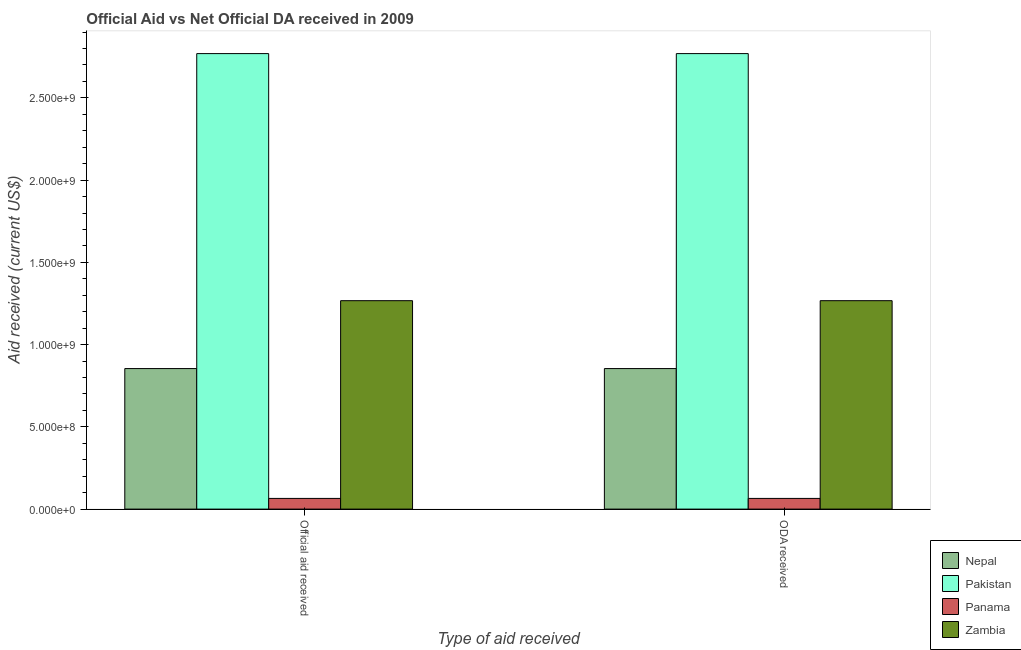How many different coloured bars are there?
Keep it short and to the point. 4. How many groups of bars are there?
Provide a short and direct response. 2. Are the number of bars on each tick of the X-axis equal?
Your answer should be very brief. Yes. How many bars are there on the 1st tick from the left?
Provide a succinct answer. 4. How many bars are there on the 1st tick from the right?
Provide a succinct answer. 4. What is the label of the 1st group of bars from the left?
Offer a terse response. Official aid received. What is the official aid received in Panama?
Your response must be concise. 6.50e+07. Across all countries, what is the maximum oda received?
Offer a terse response. 2.77e+09. Across all countries, what is the minimum oda received?
Your response must be concise. 6.50e+07. In which country was the oda received minimum?
Offer a very short reply. Panama. What is the total oda received in the graph?
Provide a succinct answer. 4.96e+09. What is the difference between the official aid received in Nepal and that in Zambia?
Keep it short and to the point. -4.13e+08. What is the difference between the oda received in Pakistan and the official aid received in Nepal?
Ensure brevity in your answer.  1.91e+09. What is the average official aid received per country?
Provide a succinct answer. 1.24e+09. What is the difference between the oda received and official aid received in Panama?
Your answer should be compact. 0. What is the ratio of the oda received in Panama to that in Pakistan?
Offer a very short reply. 0.02. Is the official aid received in Zambia less than that in Pakistan?
Give a very brief answer. Yes. What does the 4th bar from the left in ODA received represents?
Ensure brevity in your answer.  Zambia. What does the 1st bar from the right in ODA received represents?
Make the answer very short. Zambia. How many bars are there?
Keep it short and to the point. 8. Are all the bars in the graph horizontal?
Ensure brevity in your answer.  No. How many countries are there in the graph?
Provide a short and direct response. 4. What is the difference between two consecutive major ticks on the Y-axis?
Provide a short and direct response. 5.00e+08. Where does the legend appear in the graph?
Offer a terse response. Bottom right. What is the title of the graph?
Provide a succinct answer. Official Aid vs Net Official DA received in 2009 . What is the label or title of the X-axis?
Ensure brevity in your answer.  Type of aid received. What is the label or title of the Y-axis?
Ensure brevity in your answer.  Aid received (current US$). What is the Aid received (current US$) in Nepal in Official aid received?
Ensure brevity in your answer.  8.54e+08. What is the Aid received (current US$) in Pakistan in Official aid received?
Offer a terse response. 2.77e+09. What is the Aid received (current US$) of Panama in Official aid received?
Provide a short and direct response. 6.50e+07. What is the Aid received (current US$) of Zambia in Official aid received?
Give a very brief answer. 1.27e+09. What is the Aid received (current US$) in Nepal in ODA received?
Provide a succinct answer. 8.54e+08. What is the Aid received (current US$) of Pakistan in ODA received?
Your response must be concise. 2.77e+09. What is the Aid received (current US$) in Panama in ODA received?
Offer a terse response. 6.50e+07. What is the Aid received (current US$) of Zambia in ODA received?
Keep it short and to the point. 1.27e+09. Across all Type of aid received, what is the maximum Aid received (current US$) in Nepal?
Provide a succinct answer. 8.54e+08. Across all Type of aid received, what is the maximum Aid received (current US$) of Pakistan?
Make the answer very short. 2.77e+09. Across all Type of aid received, what is the maximum Aid received (current US$) of Panama?
Provide a short and direct response. 6.50e+07. Across all Type of aid received, what is the maximum Aid received (current US$) in Zambia?
Your answer should be compact. 1.27e+09. Across all Type of aid received, what is the minimum Aid received (current US$) of Nepal?
Give a very brief answer. 8.54e+08. Across all Type of aid received, what is the minimum Aid received (current US$) in Pakistan?
Your response must be concise. 2.77e+09. Across all Type of aid received, what is the minimum Aid received (current US$) in Panama?
Offer a very short reply. 6.50e+07. Across all Type of aid received, what is the minimum Aid received (current US$) of Zambia?
Ensure brevity in your answer.  1.27e+09. What is the total Aid received (current US$) of Nepal in the graph?
Offer a very short reply. 1.71e+09. What is the total Aid received (current US$) of Pakistan in the graph?
Provide a short and direct response. 5.54e+09. What is the total Aid received (current US$) of Panama in the graph?
Make the answer very short. 1.30e+08. What is the total Aid received (current US$) of Zambia in the graph?
Provide a short and direct response. 2.53e+09. What is the difference between the Aid received (current US$) of Pakistan in Official aid received and that in ODA received?
Make the answer very short. 0. What is the difference between the Aid received (current US$) of Zambia in Official aid received and that in ODA received?
Offer a terse response. 0. What is the difference between the Aid received (current US$) in Nepal in Official aid received and the Aid received (current US$) in Pakistan in ODA received?
Provide a short and direct response. -1.91e+09. What is the difference between the Aid received (current US$) of Nepal in Official aid received and the Aid received (current US$) of Panama in ODA received?
Provide a succinct answer. 7.89e+08. What is the difference between the Aid received (current US$) of Nepal in Official aid received and the Aid received (current US$) of Zambia in ODA received?
Provide a succinct answer. -4.13e+08. What is the difference between the Aid received (current US$) in Pakistan in Official aid received and the Aid received (current US$) in Panama in ODA received?
Offer a very short reply. 2.70e+09. What is the difference between the Aid received (current US$) of Pakistan in Official aid received and the Aid received (current US$) of Zambia in ODA received?
Keep it short and to the point. 1.50e+09. What is the difference between the Aid received (current US$) of Panama in Official aid received and the Aid received (current US$) of Zambia in ODA received?
Keep it short and to the point. -1.20e+09. What is the average Aid received (current US$) of Nepal per Type of aid received?
Provide a short and direct response. 8.54e+08. What is the average Aid received (current US$) of Pakistan per Type of aid received?
Keep it short and to the point. 2.77e+09. What is the average Aid received (current US$) of Panama per Type of aid received?
Give a very brief answer. 6.50e+07. What is the average Aid received (current US$) of Zambia per Type of aid received?
Provide a succinct answer. 1.27e+09. What is the difference between the Aid received (current US$) in Nepal and Aid received (current US$) in Pakistan in Official aid received?
Your response must be concise. -1.91e+09. What is the difference between the Aid received (current US$) in Nepal and Aid received (current US$) in Panama in Official aid received?
Provide a short and direct response. 7.89e+08. What is the difference between the Aid received (current US$) in Nepal and Aid received (current US$) in Zambia in Official aid received?
Ensure brevity in your answer.  -4.13e+08. What is the difference between the Aid received (current US$) of Pakistan and Aid received (current US$) of Panama in Official aid received?
Offer a very short reply. 2.70e+09. What is the difference between the Aid received (current US$) of Pakistan and Aid received (current US$) of Zambia in Official aid received?
Provide a short and direct response. 1.50e+09. What is the difference between the Aid received (current US$) in Panama and Aid received (current US$) in Zambia in Official aid received?
Your answer should be compact. -1.20e+09. What is the difference between the Aid received (current US$) in Nepal and Aid received (current US$) in Pakistan in ODA received?
Your response must be concise. -1.91e+09. What is the difference between the Aid received (current US$) in Nepal and Aid received (current US$) in Panama in ODA received?
Keep it short and to the point. 7.89e+08. What is the difference between the Aid received (current US$) of Nepal and Aid received (current US$) of Zambia in ODA received?
Provide a short and direct response. -4.13e+08. What is the difference between the Aid received (current US$) of Pakistan and Aid received (current US$) of Panama in ODA received?
Your response must be concise. 2.70e+09. What is the difference between the Aid received (current US$) of Pakistan and Aid received (current US$) of Zambia in ODA received?
Your answer should be very brief. 1.50e+09. What is the difference between the Aid received (current US$) of Panama and Aid received (current US$) of Zambia in ODA received?
Ensure brevity in your answer.  -1.20e+09. What is the difference between the highest and the second highest Aid received (current US$) of Nepal?
Provide a succinct answer. 0. What is the difference between the highest and the lowest Aid received (current US$) in Nepal?
Your response must be concise. 0. What is the difference between the highest and the lowest Aid received (current US$) in Pakistan?
Your response must be concise. 0. What is the difference between the highest and the lowest Aid received (current US$) of Panama?
Keep it short and to the point. 0. What is the difference between the highest and the lowest Aid received (current US$) in Zambia?
Offer a very short reply. 0. 